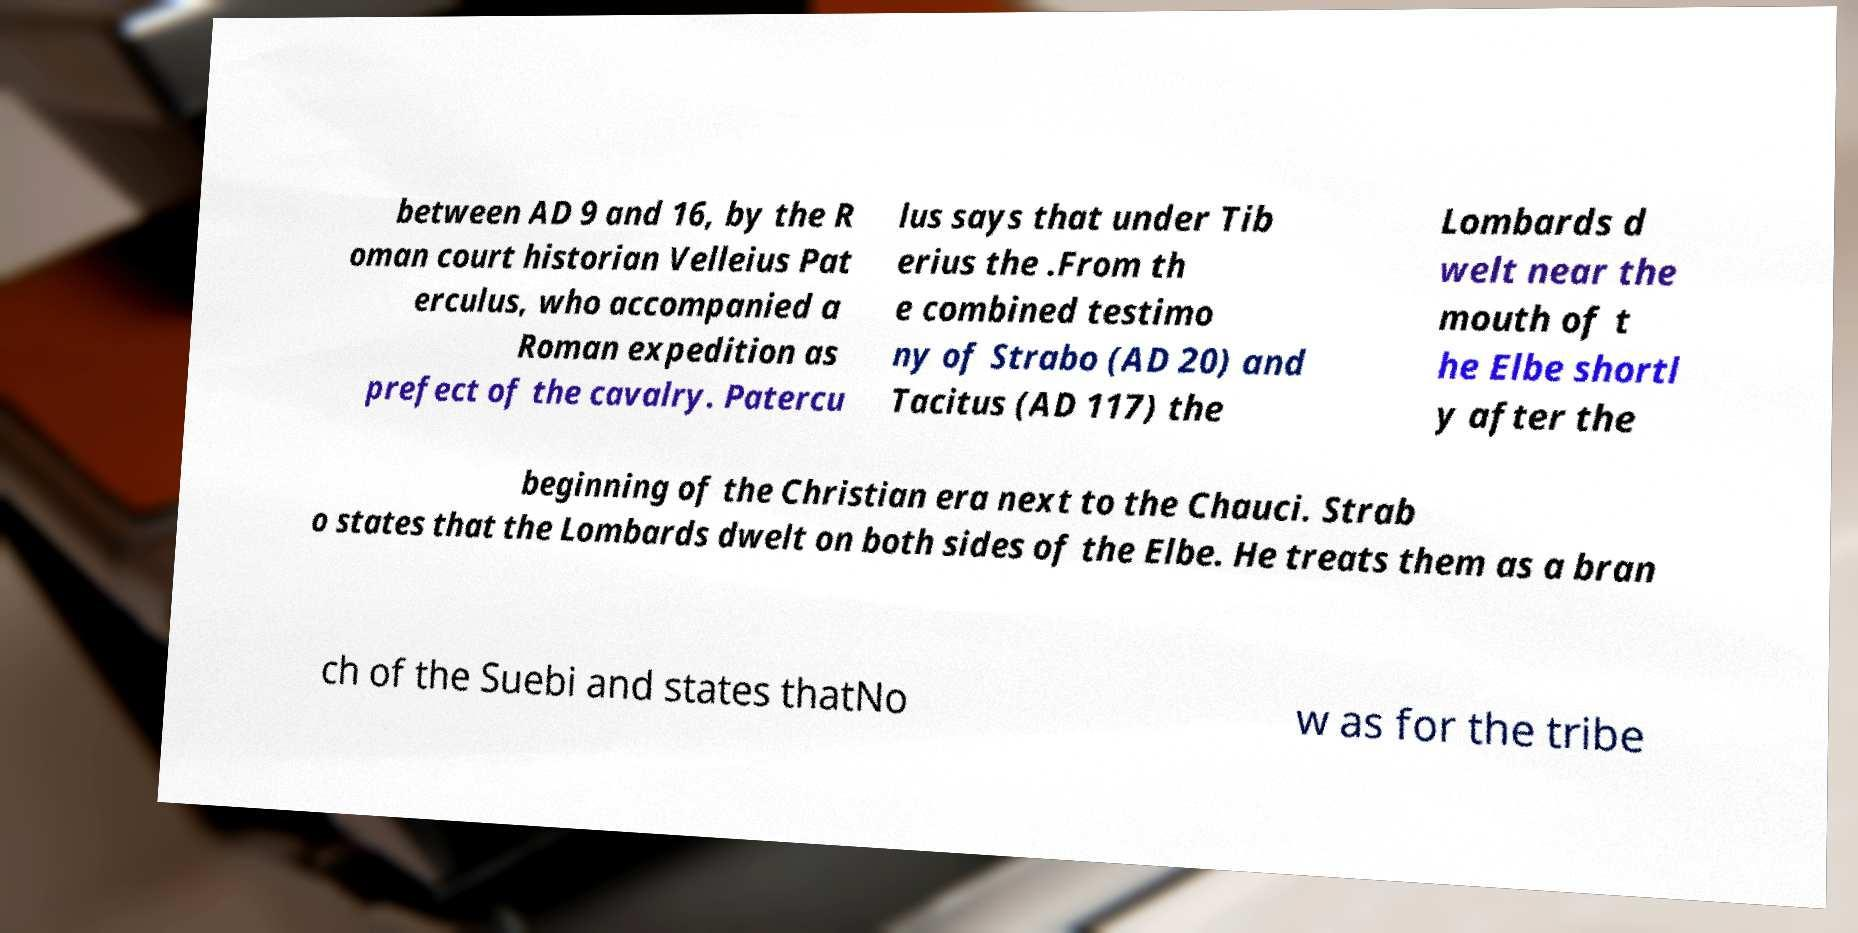Could you assist in decoding the text presented in this image and type it out clearly? between AD 9 and 16, by the R oman court historian Velleius Pat erculus, who accompanied a Roman expedition as prefect of the cavalry. Patercu lus says that under Tib erius the .From th e combined testimo ny of Strabo (AD 20) and Tacitus (AD 117) the Lombards d welt near the mouth of t he Elbe shortl y after the beginning of the Christian era next to the Chauci. Strab o states that the Lombards dwelt on both sides of the Elbe. He treats them as a bran ch of the Suebi and states thatNo w as for the tribe 